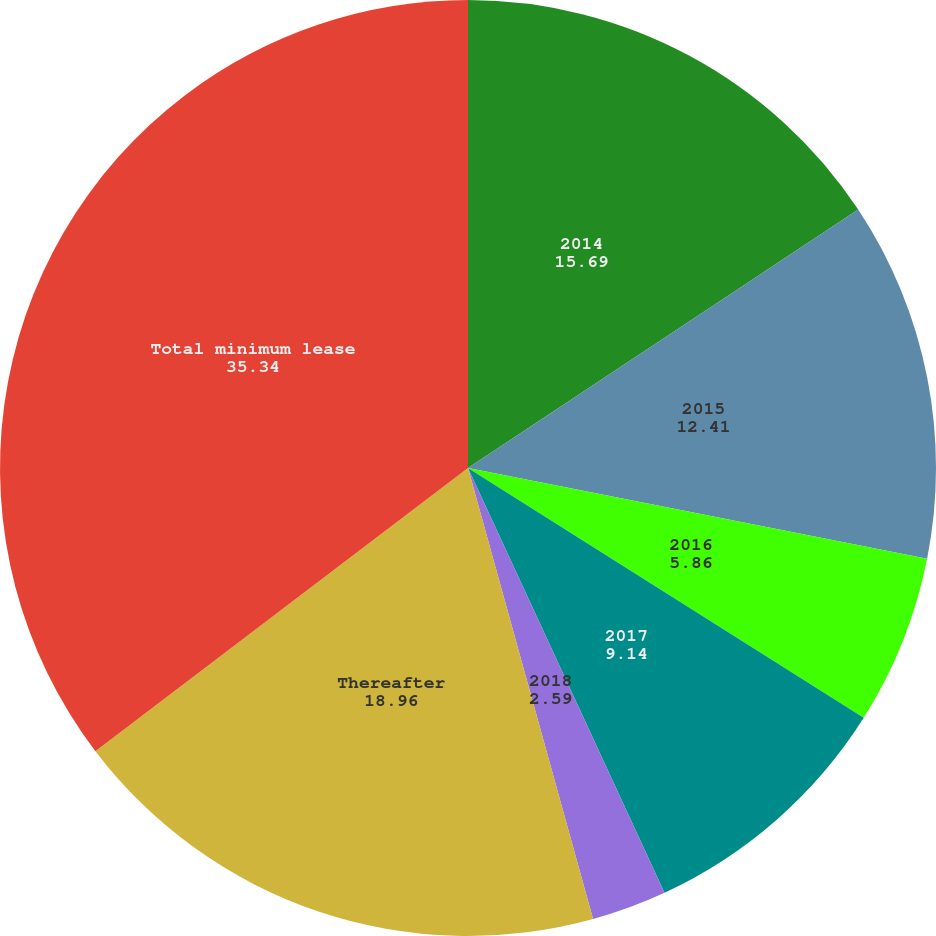Convert chart. <chart><loc_0><loc_0><loc_500><loc_500><pie_chart><fcel>2014<fcel>2015<fcel>2016<fcel>2017<fcel>2018<fcel>Thereafter<fcel>Total minimum lease<nl><fcel>15.69%<fcel>12.41%<fcel>5.86%<fcel>9.14%<fcel>2.59%<fcel>18.96%<fcel>35.34%<nl></chart> 